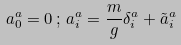Convert formula to latex. <formula><loc_0><loc_0><loc_500><loc_500>a ^ { a } _ { 0 } = 0 \, ; \, a ^ { a } _ { i } = \frac { m } { g } \delta ^ { a } _ { i } + { \tilde { a } } _ { i } ^ { a }</formula> 